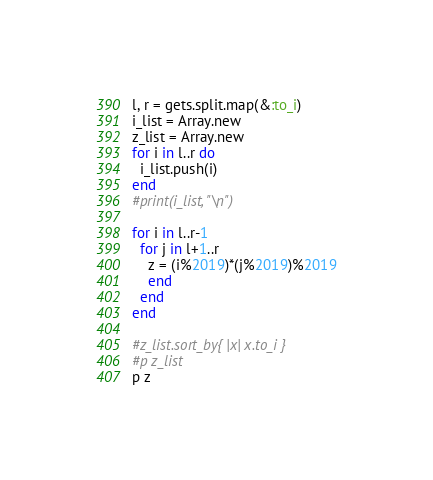Convert code to text. <code><loc_0><loc_0><loc_500><loc_500><_Ruby_>l, r = gets.split.map(&:to_i)
i_list = Array.new
z_list = Array.new
for i in l..r do
  i_list.push(i)
end
#print(i_list, "\n")

for i in l..r-1
  for j in l+1..r
    z = (i%2019)*(j%2019)%2019
    end
  end
end

#z_list.sort_by{ |x| x.to_i }
#p z_list
p z</code> 